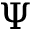<formula> <loc_0><loc_0><loc_500><loc_500>\Psi</formula> 